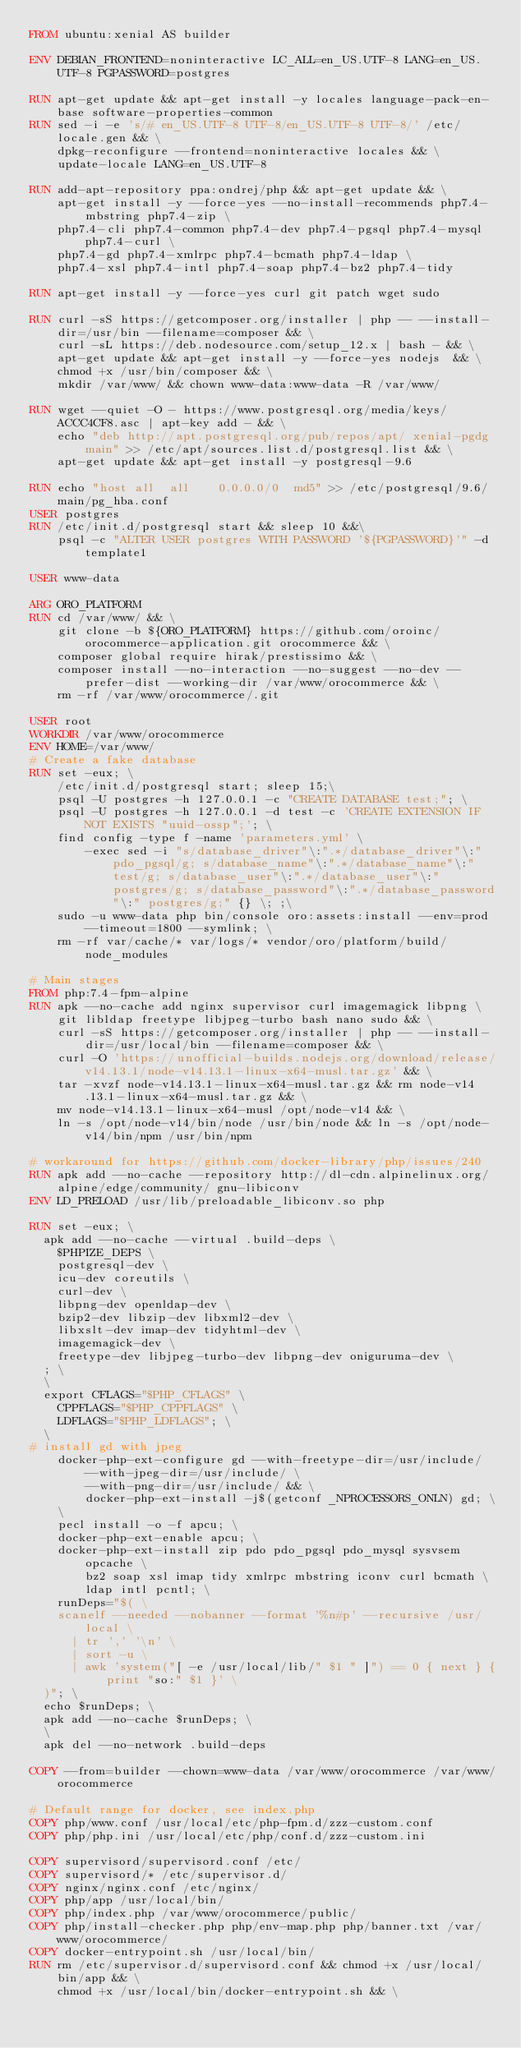Convert code to text. <code><loc_0><loc_0><loc_500><loc_500><_Dockerfile_>FROM ubuntu:xenial AS builder

ENV DEBIAN_FRONTEND=noninteractive LC_ALL=en_US.UTF-8 LANG=en_US.UTF-8 PGPASSWORD=postgres

RUN apt-get update && apt-get install -y locales language-pack-en-base software-properties-common
RUN sed -i -e 's/# en_US.UTF-8 UTF-8/en_US.UTF-8 UTF-8/' /etc/locale.gen && \
    dpkg-reconfigure --frontend=noninteractive locales && \
    update-locale LANG=en_US.UTF-8

RUN add-apt-repository ppa:ondrej/php && apt-get update && \
    apt-get install -y --force-yes --no-install-recommends php7.4-mbstring php7.4-zip \
    php7.4-cli php7.4-common php7.4-dev php7.4-pgsql php7.4-mysql php7.4-curl \
    php7.4-gd php7.4-xmlrpc php7.4-bcmath php7.4-ldap \
    php7.4-xsl php7.4-intl php7.4-soap php7.4-bz2 php7.4-tidy

RUN apt-get install -y --force-yes curl git patch wget sudo

RUN curl -sS https://getcomposer.org/installer | php -- --install-dir=/usr/bin --filename=composer && \
    curl -sL https://deb.nodesource.com/setup_12.x | bash - && \
    apt-get update && apt-get install -y --force-yes nodejs  && \
    chmod +x /usr/bin/composer && \
    mkdir /var/www/ && chown www-data:www-data -R /var/www/

RUN wget --quiet -O - https://www.postgresql.org/media/keys/ACCC4CF8.asc | apt-key add - && \
    echo "deb http://apt.postgresql.org/pub/repos/apt/ xenial-pgdg main" >> /etc/apt/sources.list.d/postgresql.list && \
    apt-get update && apt-get install -y postgresql-9.6

RUN echo "host all  all    0.0.0.0/0  md5" >> /etc/postgresql/9.6/main/pg_hba.conf
USER postgres
RUN /etc/init.d/postgresql start && sleep 10 &&\
    psql -c "ALTER USER postgres WITH PASSWORD '${PGPASSWORD}'" -d template1

USER www-data

ARG ORO_PLATFORM
RUN cd /var/www/ && \
    git clone -b ${ORO_PLATFORM} https://github.com/oroinc/orocommerce-application.git orocommerce && \
    composer global require hirak/prestissimo && \
    composer install --no-interaction --no-suggest --no-dev --prefer-dist --working-dir /var/www/orocommerce && \
    rm -rf /var/www/orocommerce/.git

USER root
WORKDIR /var/www/orocommerce
ENV HOME=/var/www/
# Create a fake database
RUN set -eux; \
    /etc/init.d/postgresql start; sleep 15;\
    psql -U postgres -h 127.0.0.1 -c "CREATE DATABASE test;"; \
    psql -U postgres -h 127.0.0.1 -d test -c 'CREATE EXTENSION IF NOT EXISTS "uuid-ossp";'; \
    find config -type f -name 'parameters.yml' \
        -exec sed -i "s/database_driver"\:".*/database_driver"\:" pdo_pgsql/g; s/database_name"\:".*/database_name"\:" test/g; s/database_user"\:".*/database_user"\:" postgres/g; s/database_password"\:".*/database_password"\:" postgres/g;" {} \; ;\
    sudo -u www-data php bin/console oro:assets:install --env=prod --timeout=1800 --symlink; \
    rm -rf var/cache/* var/logs/* vendor/oro/platform/build/node_modules

# Main stages
FROM php:7.4-fpm-alpine
RUN apk --no-cache add nginx supervisor curl imagemagick libpng \
    git libldap freetype libjpeg-turbo bash nano sudo && \
    curl -sS https://getcomposer.org/installer | php -- --install-dir=/usr/local/bin --filename=composer && \
    curl -O 'https://unofficial-builds.nodejs.org/download/release/v14.13.1/node-v14.13.1-linux-x64-musl.tar.gz' && \
    tar -xvzf node-v14.13.1-linux-x64-musl.tar.gz && rm node-v14.13.1-linux-x64-musl.tar.gz && \
    mv node-v14.13.1-linux-x64-musl /opt/node-v14 && \
    ln -s /opt/node-v14/bin/node /usr/bin/node && ln -s /opt/node-v14/bin/npm /usr/bin/npm

# workaround for https://github.com/docker-library/php/issues/240
RUN apk add --no-cache --repository http://dl-cdn.alpinelinux.org/alpine/edge/community/ gnu-libiconv
ENV LD_PRELOAD /usr/lib/preloadable_libiconv.so php

RUN set -eux; \
	apk add --no-cache --virtual .build-deps \
		$PHPIZE_DEPS \
		postgresql-dev \
		icu-dev coreutils \
		curl-dev \
		libpng-dev openldap-dev \
		bzip2-dev libzip-dev libxml2-dev \
		libxslt-dev imap-dev tidyhtml-dev \
		imagemagick-dev \
		freetype-dev libjpeg-turbo-dev libpng-dev oniguruma-dev \
	; \
	\
	export CFLAGS="$PHP_CFLAGS" \
		CPPFLAGS="$PHP_CPPFLAGS" \
		LDFLAGS="$PHP_LDFLAGS"; \
	\
#	install gd with jpeg
    docker-php-ext-configure gd --with-freetype-dir=/usr/include/ --with-jpeg-dir=/usr/include/ \
        --with-png-dir=/usr/include/ && \
        docker-php-ext-install -j$(getconf _NPROCESSORS_ONLN) gd; \
    \
    pecl install -o -f apcu; \
    docker-php-ext-enable apcu; \
    docker-php-ext-install zip pdo pdo_pgsql pdo_mysql sysvsem opcache \
        bz2 soap xsl imap tidy xmlrpc mbstring iconv curl bcmath \
        ldap intl pcntl; \
    runDeps="$( \
		scanelf --needed --nobanner --format '%n#p' --recursive /usr/local \
			| tr ',' '\n' \
			| sort -u \
			| awk 'system("[ -e /usr/local/lib/" $1 " ]") == 0 { next } { print "so:" $1 }' \
	)"; \
	echo $runDeps; \
	apk add --no-cache $runDeps; \
	\
	apk del --no-network .build-deps

COPY --from=builder --chown=www-data /var/www/orocommerce /var/www/orocommerce

# Default range for docker, see index.php
COPY php/www.conf /usr/local/etc/php-fpm.d/zzz-custom.conf
COPY php/php.ini /usr/local/etc/php/conf.d/zzz-custom.ini

COPY supervisord/supervisord.conf /etc/
COPY supervisord/* /etc/supervisor.d/
COPY nginx/nginx.conf /etc/nginx/
COPY php/app /usr/local/bin/
COPY php/index.php /var/www/orocommerce/public/
COPY php/install-checker.php php/env-map.php php/banner.txt /var/www/orocommerce/
COPY docker-entrypoint.sh /usr/local/bin/
RUN rm /etc/supervisor.d/supervisord.conf && chmod +x /usr/local/bin/app && \
    chmod +x /usr/local/bin/docker-entrypoint.sh && \</code> 